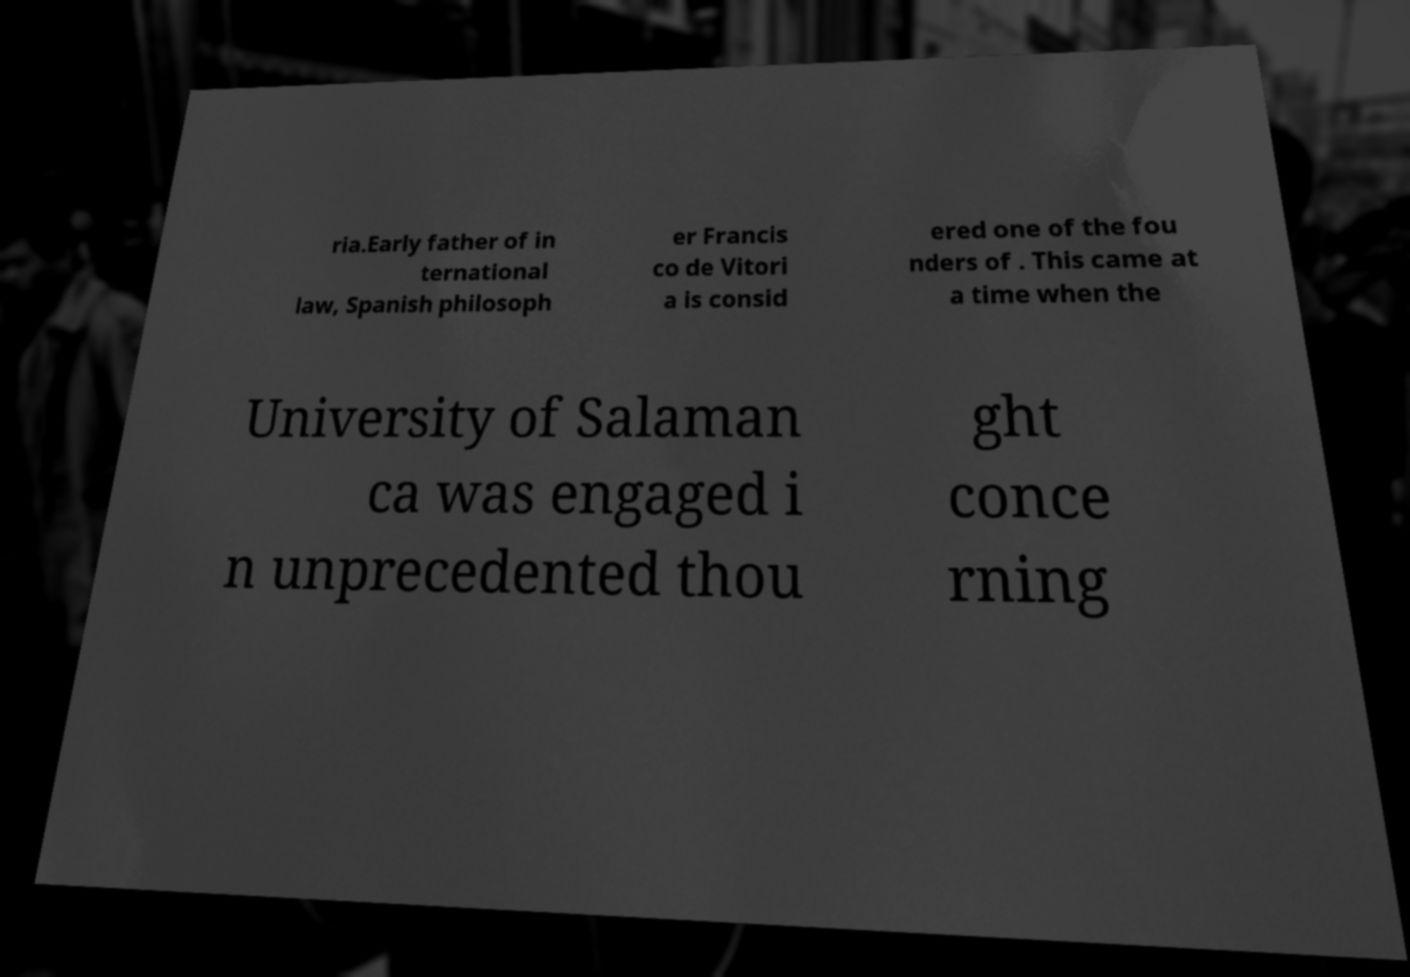Can you accurately transcribe the text from the provided image for me? ria.Early father of in ternational law, Spanish philosoph er Francis co de Vitori a is consid ered one of the fou nders of . This came at a time when the University of Salaman ca was engaged i n unprecedented thou ght conce rning 